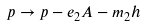<formula> <loc_0><loc_0><loc_500><loc_500>p \rightarrow p - e _ { 2 } A - m _ { 2 } h \text { }</formula> 